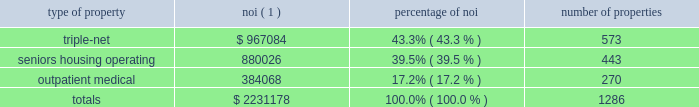Item 7 .
Management 2019s discussion and analysis of financial condition and results of operations the following discussion and analysis is based primarily on the consolidated financial statements of welltower inc .
Presented in conformity with u.s .
Generally accepted accounting principles ( 201cu.s .
Gaap 201d ) for the periods presented and should be read together with the notes thereto contained in this annual report on form 10-k .
Other important factors are identified in 201citem 1 2014 business 201d and 201citem 1a 2014 risk factors 201d above .
Executive summary company overview welltower inc .
( nyse:well ) , an s&p 500 company headquartered in toledo , ohio , is driving the transformation of health care infrastructure .
The company invests with leading seniors housing operators , post- acute providers and health systems to fund the real estate and infrastructure needed to scale innovative care delivery models and improve people 2019s wellness and overall health care experience .
Welltowertm , a real estate investment trust ( 201creit 201d ) , owns interests in properties concentrated in major , high-growth markets in the united states ( 201cu.s . 201d ) , canada and the united kingdom ( 201cu.k . 201d ) , consisting of seniors housing and post-acute communities and outpatient medical properties .
Our capital programs , when combined with comprehensive planning , development and property management services , make us a single-source solution for acquiring , planning , developing , managing , repositioning and monetizing real estate assets .
The table summarizes our consolidated portfolio for the year ended december 31 , 2017 ( dollars in thousands ) : type of property noi ( 1 ) percentage of number of properties .
( 1 ) represents consolidated noi and excludes our share of investments in unconsolidated entities .
Entities in which we have a joint venture with a minority partner are shown at 100% ( 100 % ) of the joint venture amount .
See non-gaap financial measures for additional information and reconciliation .
Business strategy our primary objectives are to protect stockholder capital and enhance stockholder value .
We seek to pay consistent cash dividends to stockholders and create opportunities to increase dividend payments to stockholders as a result of annual increases in net operating income and portfolio growth .
To meet these objectives , we invest across the full spectrum of seniors housing and health care real estate and diversify our investment portfolio by property type , relationship and geographic location .
Substantially all of our revenues are derived from operating lease rentals , resident fees/services , and interest earned on outstanding loans receivable .
These items represent our primary sources of liquidity to fund distributions and depend upon the continued ability of our obligors to make contractual rent and interest payments to us and the profitability of our operating properties .
To the extent that our obligors/partners experience operating difficulties and become unable to generate sufficient cash to make payments or operating distributions to us , there could be a material adverse impact on our consolidated results of operations , liquidity and/or financial condition .
To mitigate this risk , we monitor our investments through a variety of methods determined by the type of property .
Our asset management process for seniors housing properties generally includes review of monthly financial statements and other operating data for each property , review of obligor/ partner creditworthiness , property inspections , and review of covenant compliance relating to licensure , real estate taxes , letters of credit and other collateral .
Our internal property management division manages and monitors the outpatient medical portfolio with a comprehensive process including review of tenant relations .
What portion of the total number of properties is related to seniors housing operating? 
Computations: (443 / 1286)
Answer: 0.34448. 